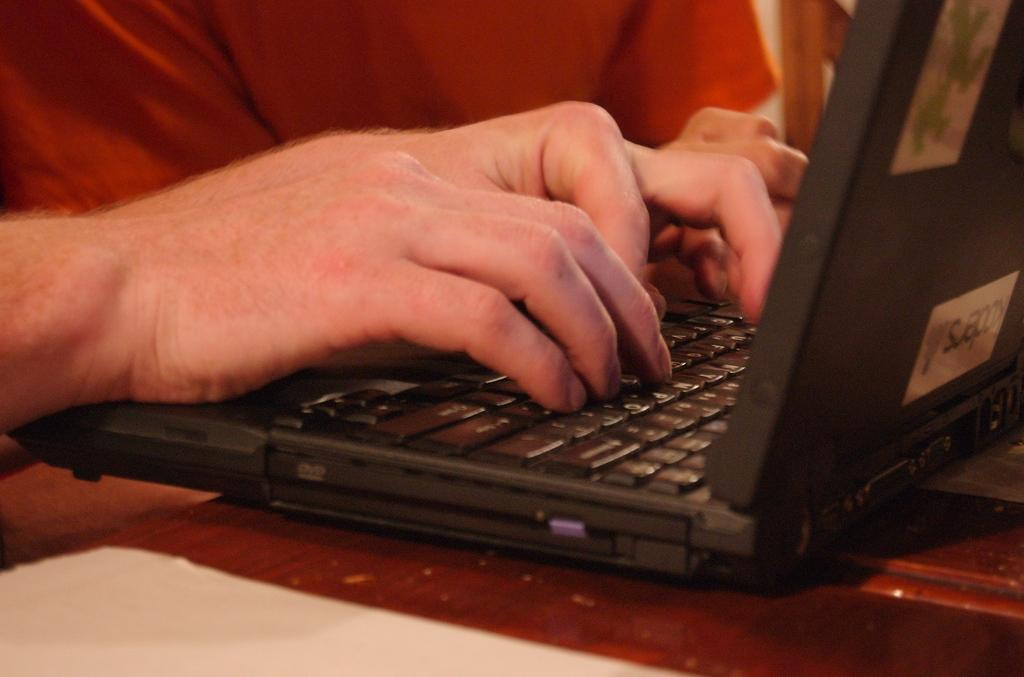What is present on the table in the image? There is a paper and a laptop on the table in the image. What is the person in front of in the image? The person is in front of the laptop. What might the person be doing with the laptop? The person might be working, browsing the internet, or using the laptop for some other purpose. How many tickets can be seen on the table in the image? There are no tickets present on the table in the image. What type of bird is perched on the laptop in the image? There is no bird, specifically a wren, present on the laptop in the image. 